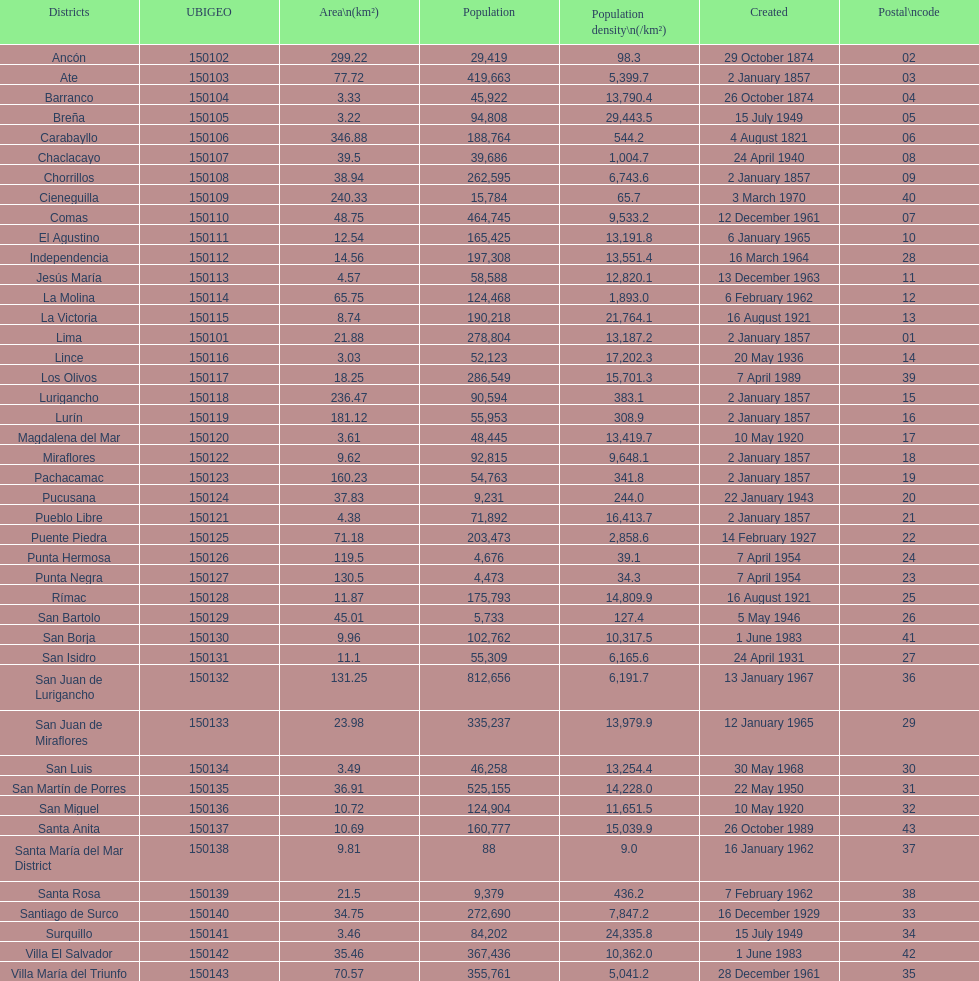What was the last district created? Santa Anita. 